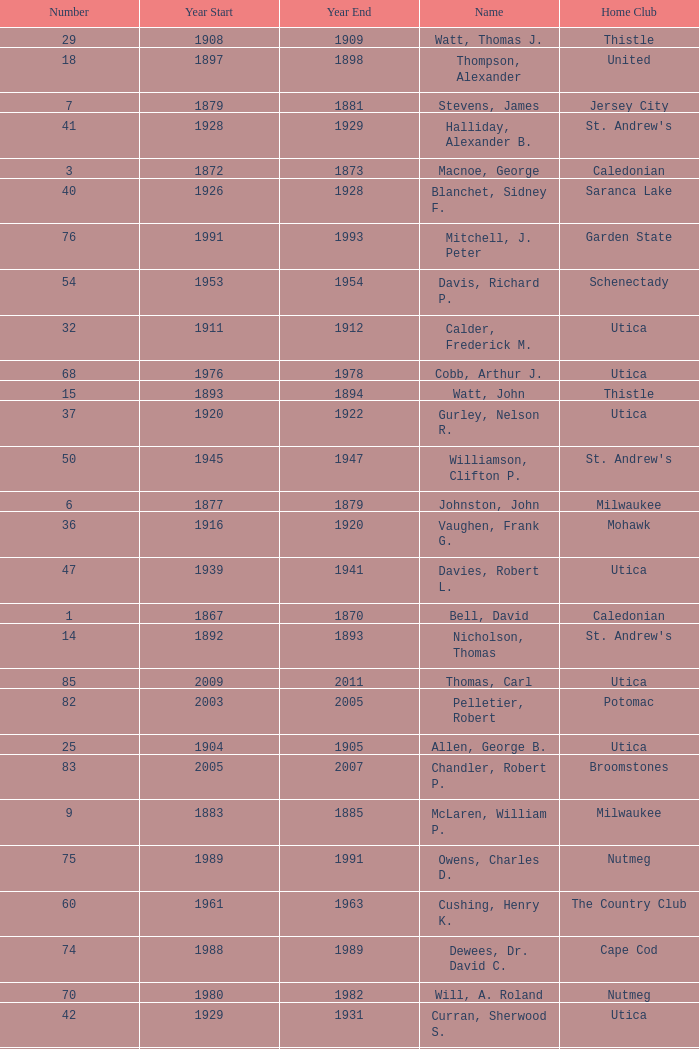Which Number has a Year Start smaller than 1874, and a Year End larger than 1873? 4.0. 